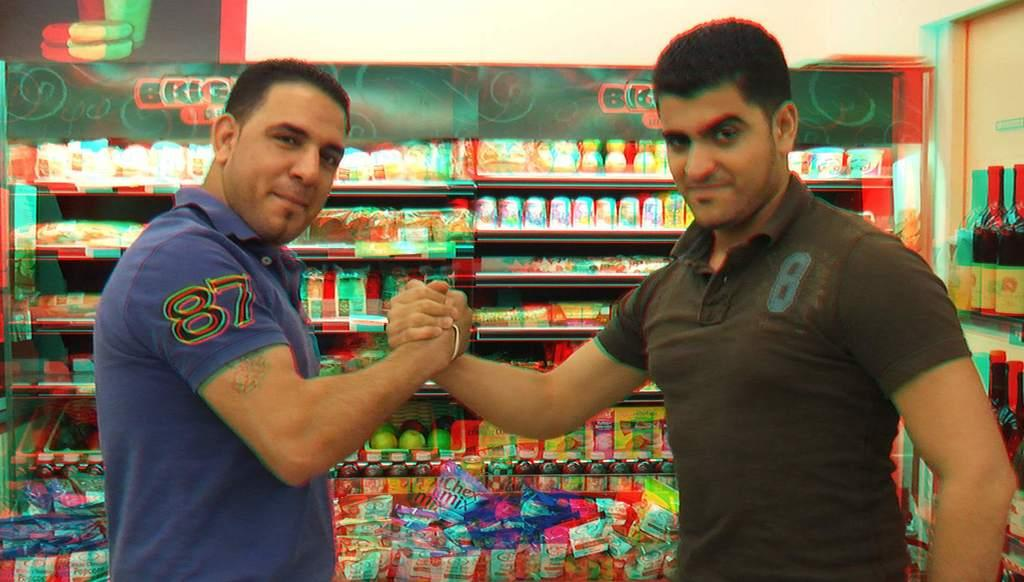<image>
Present a compact description of the photo's key features. Two men, one wearing #87 and one wearing #8 lock arms for a photo. 